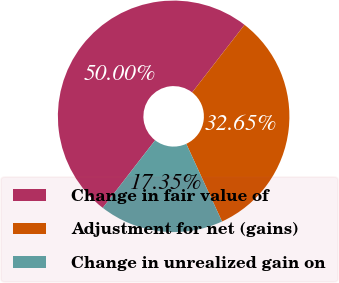<chart> <loc_0><loc_0><loc_500><loc_500><pie_chart><fcel>Change in fair value of<fcel>Adjustment for net (gains)<fcel>Change in unrealized gain on<nl><fcel>50.0%<fcel>32.65%<fcel>17.35%<nl></chart> 